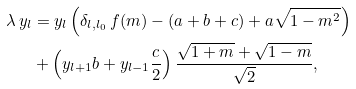<formula> <loc_0><loc_0><loc_500><loc_500>\lambda \, y _ { l } & = y _ { l } \left ( \delta _ { l , l _ { 0 } } \, f ( m ) - ( a + b + c ) + a \sqrt { 1 - m ^ { 2 } } \right ) \\ & + \left ( y _ { l + 1 } b + y _ { l - 1 } \frac { c } { 2 } \right ) \frac { \sqrt { 1 + m } + \sqrt { 1 - m } } { \sqrt { 2 } } ,</formula> 